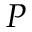<formula> <loc_0><loc_0><loc_500><loc_500>P</formula> 